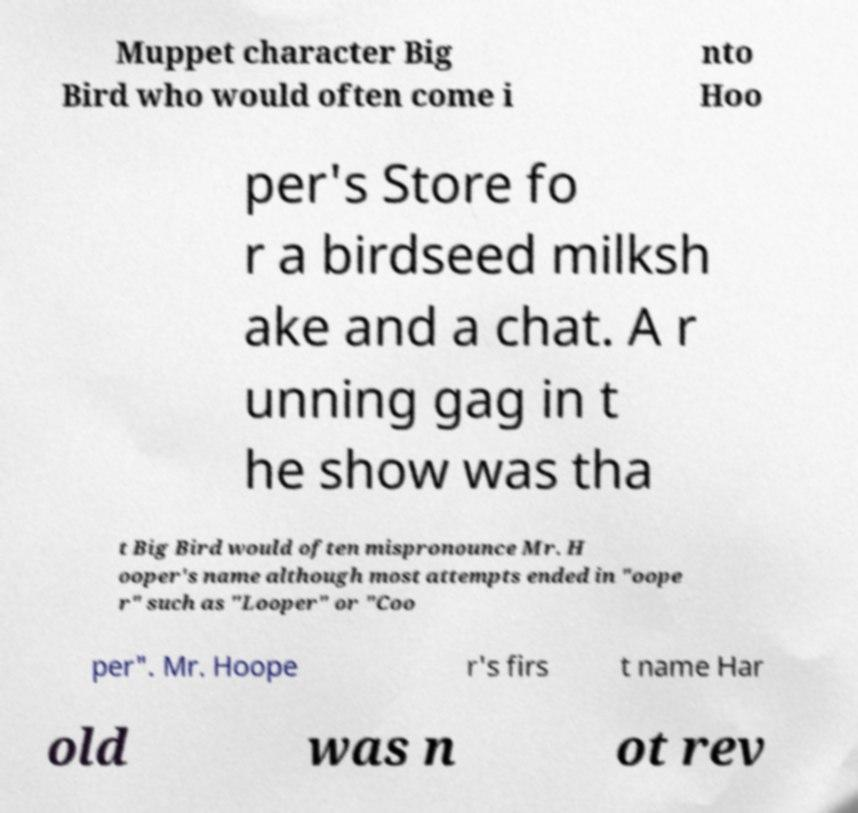Please identify and transcribe the text found in this image. Muppet character Big Bird who would often come i nto Hoo per's Store fo r a birdseed milksh ake and a chat. A r unning gag in t he show was tha t Big Bird would often mispronounce Mr. H ooper's name although most attempts ended in "oope r" such as "Looper" or "Coo per". Mr. Hoope r's firs t name Har old was n ot rev 